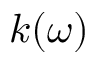Convert formula to latex. <formula><loc_0><loc_0><loc_500><loc_500>k ( \omega )</formula> 